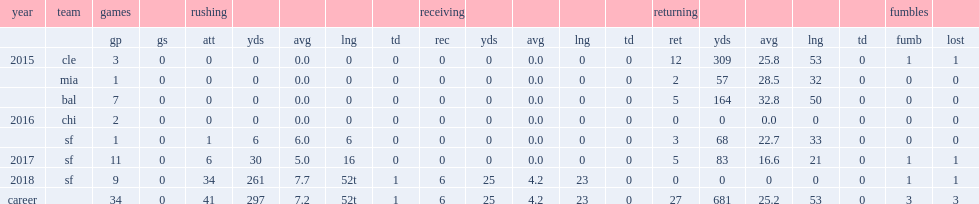How many rushing yards did mostert get in 2018? 261.0. 